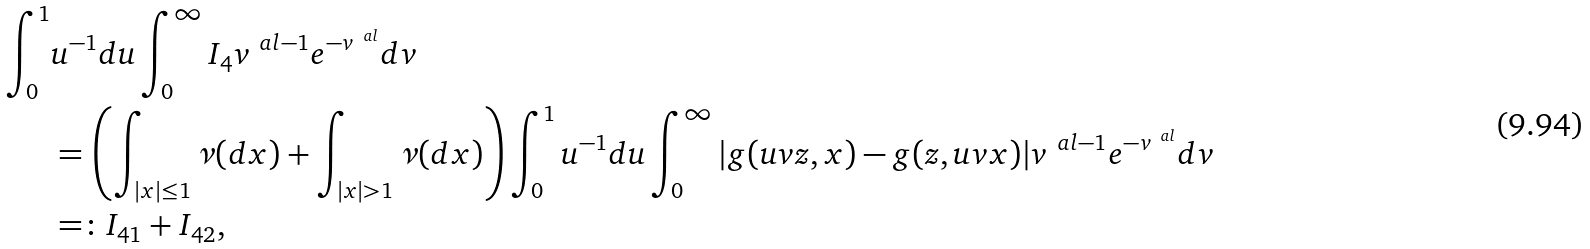<formula> <loc_0><loc_0><loc_500><loc_500>\int _ { 0 } ^ { 1 } & u ^ { - 1 } d u \int _ { 0 } ^ { \infty } I _ { 4 } v ^ { \ a l - 1 } e ^ { - v ^ { \ a l } } d v \\ & = \left ( \int _ { | x | \leq 1 } \nu ( d x ) + \int _ { | x | > 1 } \nu ( d x ) \right ) \int _ { 0 } ^ { 1 } u ^ { - 1 } d u \int _ { 0 } ^ { \infty } | g ( u v z , x ) - g ( z , u v x ) | v ^ { \ a l - 1 } e ^ { - v ^ { \ a l } } d v \\ & = \colon I _ { 4 1 } + I _ { 4 2 } ,</formula> 